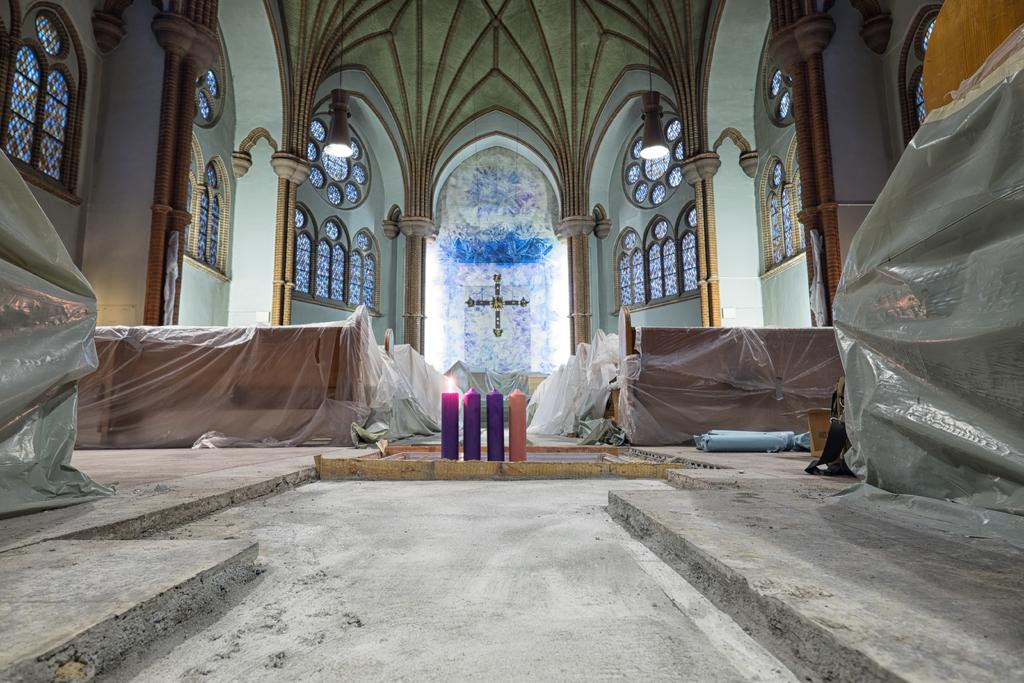What type of building is shown in the image? The image is an inside view of a church. Are there any light sources visible in the image? Yes, there are lights in the image. What religious symbol can be seen in the image? There is a cross in the image. What type of illumination is present in the image? There are candles in the image, with at least one being lighted. What might be the purpose of the boxes in the image? The boxes in the image appear to be packed, which suggests they might be used for storage or transportation. What surface is visible in the image? There is a floor visible in the image. What letter is the manager writing to the congregation in the image? There is no manager or letter present in the image; it is a view of the inside of a church with various religious symbols and objects. 